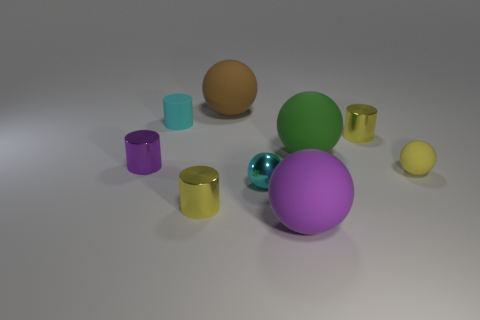What are the different materials that appear to be represented by the objects, and can you identify which object corresponds to each material? The objects in the image seem to depict at least three different types of material finishes. The lavender sphere in the center and the two cylinders, one purple and one gold, have a metallic sheen. The green and orange spheres have a matte finish, looking like rubber or plastic. The cyan object, likely another sphere, exhibits transparency, suggesting it is made of glass or a similar material. 